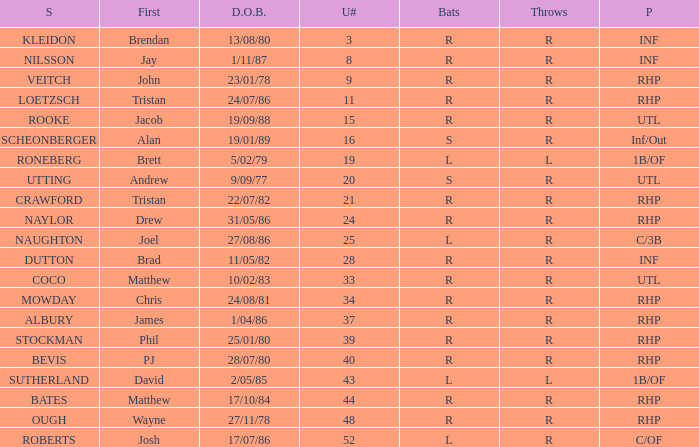Which Surname has Throws of l, and a DOB of 5/02/79? RONEBERG. Parse the table in full. {'header': ['S', 'First', 'D.O.B.', 'U#', 'Bats', 'Throws', 'P'], 'rows': [['KLEIDON', 'Brendan', '13/08/80', '3', 'R', 'R', 'INF'], ['NILSSON', 'Jay', '1/11/87', '8', 'R', 'R', 'INF'], ['VEITCH', 'John', '23/01/78', '9', 'R', 'R', 'RHP'], ['LOETZSCH', 'Tristan', '24/07/86', '11', 'R', 'R', 'RHP'], ['ROOKE', 'Jacob', '19/09/88', '15', 'R', 'R', 'UTL'], ['SCHEONBERGER', 'Alan', '19/01/89', '16', 'S', 'R', 'Inf/Out'], ['RONEBERG', 'Brett', '5/02/79', '19', 'L', 'L', '1B/OF'], ['UTTING', 'Andrew', '9/09/77', '20', 'S', 'R', 'UTL'], ['CRAWFORD', 'Tristan', '22/07/82', '21', 'R', 'R', 'RHP'], ['NAYLOR', 'Drew', '31/05/86', '24', 'R', 'R', 'RHP'], ['NAUGHTON', 'Joel', '27/08/86', '25', 'L', 'R', 'C/3B'], ['DUTTON', 'Brad', '11/05/82', '28', 'R', 'R', 'INF'], ['COCO', 'Matthew', '10/02/83', '33', 'R', 'R', 'UTL'], ['MOWDAY', 'Chris', '24/08/81', '34', 'R', 'R', 'RHP'], ['ALBURY', 'James', '1/04/86', '37', 'R', 'R', 'RHP'], ['STOCKMAN', 'Phil', '25/01/80', '39', 'R', 'R', 'RHP'], ['BEVIS', 'PJ', '28/07/80', '40', 'R', 'R', 'RHP'], ['SUTHERLAND', 'David', '2/05/85', '43', 'L', 'L', '1B/OF'], ['BATES', 'Matthew', '17/10/84', '44', 'R', 'R', 'RHP'], ['OUGH', 'Wayne', '27/11/78', '48', 'R', 'R', 'RHP'], ['ROBERTS', 'Josh', '17/07/86', '52', 'L', 'R', 'C/OF']]} 